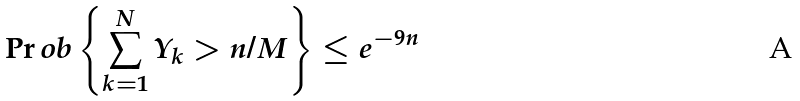Convert formula to latex. <formula><loc_0><loc_0><loc_500><loc_500>\Pr o b \left \{ \sum _ { k = 1 } ^ { N } Y _ { k } > n / M \right \} \leq e ^ { - 9 n }</formula> 